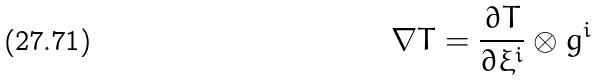<formula> <loc_0><loc_0><loc_500><loc_500>\nabla T = \frac { \partial T } { \partial \xi ^ { i } } \otimes g ^ { i }</formula> 